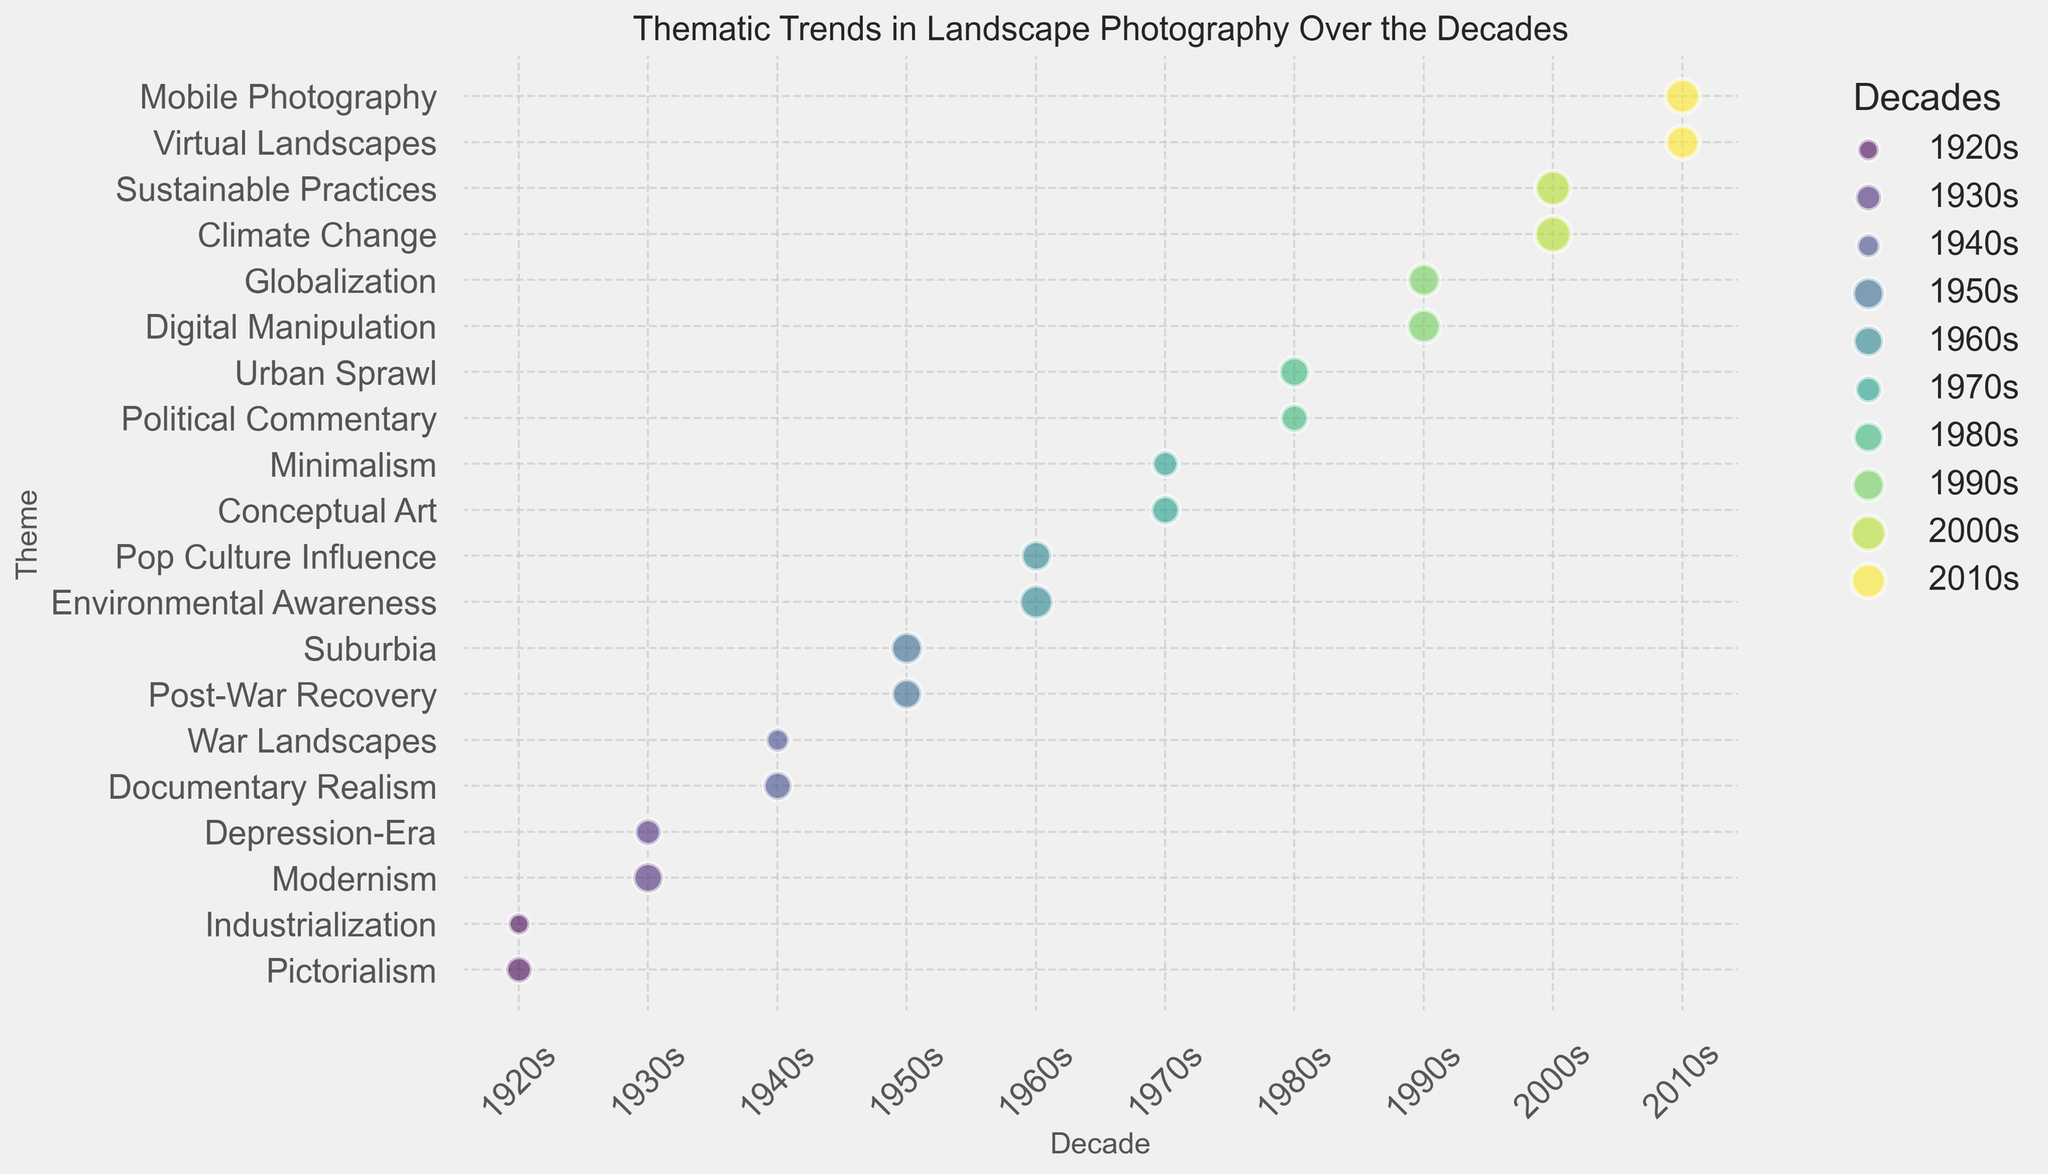What decade shows the highest frequency for the theme of Environmental Awareness? By observing the size of the bubbles, the 1960s shows a notably large bubble for the theme of Environmental Awareness, indicating a high frequency, larger than any other decade for this theme.
Answer: 1960s Which theme has a bubble with the largest size in the 2000s? Compare the sizes of the bubbles in the 2000s, where the bubbles for Climate Change and Sustainable Practices are considerably large. Climate Change has the largest bubble.
Answer: Climate Change Between the themes of Pictorialism and Digital Manipulation, which one shows a higher impact? The impact for Pictorialism in the 1920s is given as 5, while the impact for Digital Manipulation in the 1990s is specified as 9. Thus, Digital Manipulation has a higher impact.
Answer: Digital Manipulation How many themes in the 1990s have an impact value of 8 or more? In the 1990s, the themes are Digital Manipulation (impact 9) and Globalization (impact 8). Both meet the criteria of having an impact of 8 or more.
Answer: 2 Which decade has more themes with a frequency greater than 20? In the 1990s, Digital Manipulation (25) and Globalization (23) surpass a frequency of 20. In the 2000s, Climate Change (30) and Sustainable Practices (28) also surpass a frequency of 20. Both decades have an equal number.
Answer: Both What is the average impact of the themes in the 1940s? The impact values in the 1940s are 6 (Documentary Realism) and 9 (War Landscapes). The average is calculated as (6 + 9) / 2 = 7.5
Answer: 7.5 Does the theme of Minimalism in the 1970s have a higher frequency than War Landscapes in the 1940s? The frequency for Minimalism in the 1970s is 15, while for War Landscapes in the 1940s is 12. Thus, Minimalism has a higher frequency.
Answer: Yes Which decade has the smallest bubble for any theme, and what is that theme? By comparing the smallest bubbles across decades, the 1920s has the smallest bubble for Industrialization with a frequency of 10.
Answer: 1920s, Industrialization Comparing the theme of Environmental Awareness in the 1960s and the theme of Climate Change in the 2000s, which has a higher impact? Environmental Awareness in the 1960s has an impact of 9, while Climate Change in the 2000s has an impact of 10. Thus, Climate Change has a higher impact.
Answer: Climate Change How does the frequency of Virtual Landscapes in the 2010s compare to that of Urban Sprawl in the 1980s? The frequency of Virtual Landscapes in the 2010s is 25, while for Urban Sprawl in the 1980s it is 20. Therefore, Virtual Landscapes has a higher frequency.
Answer: Virtual Landscapes 